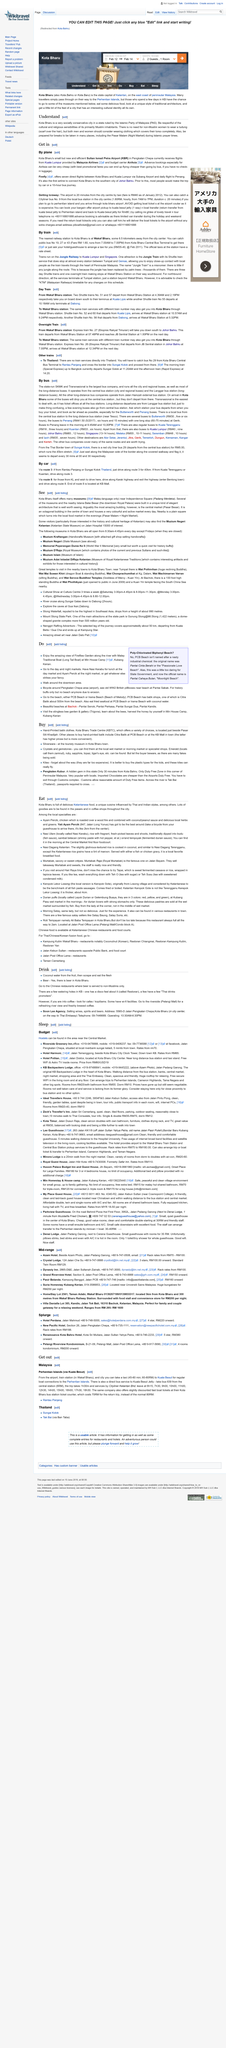Give some essential details in this illustration. The English translation of 'Pasar Malam' is 'Night Market'. There are two guests. Firefly, Malaysia Airlines, and AirAsia offer flights from Kuala Lumpur. AirAsia offers the cheapest flights when advance booking is done. The new airport in Pengkalan Chepa is called Sultan Ismail Petra Airport, and it is located in Pengkalan Chepa. 